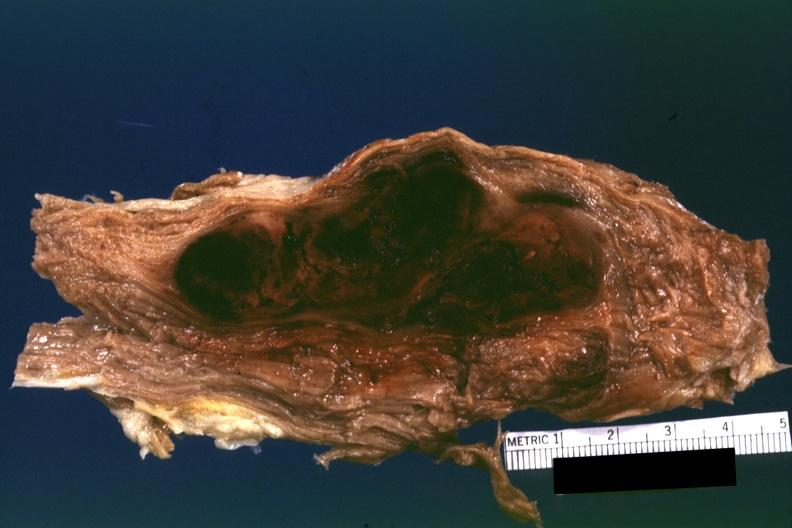does so the diagnosis on all other slides of this case in this file need to be changed?
Answer the question using a single word or phrase. Yes 